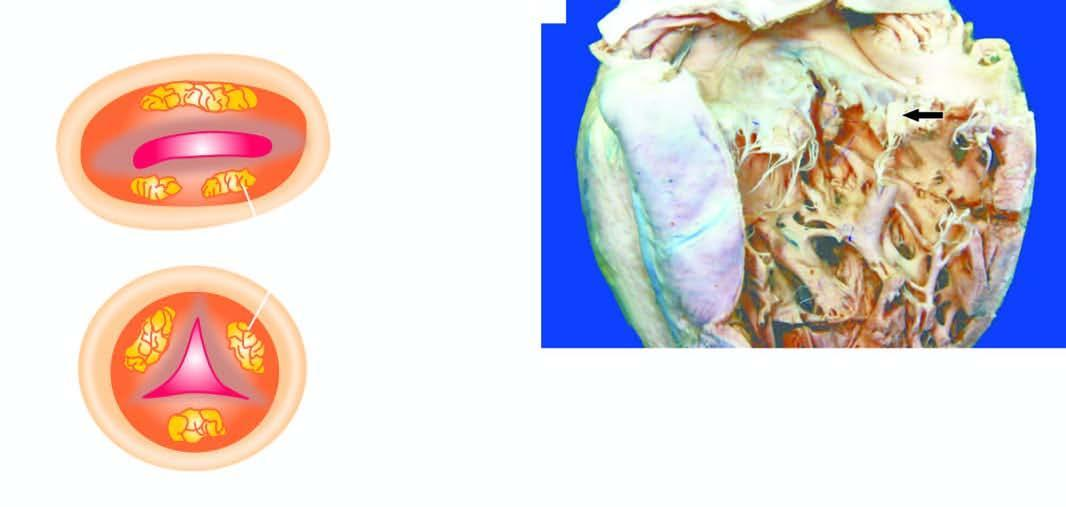what are shown on the mitral valve are shown as seen from the left ventricle?
Answer the question using a single word or phrase. Vegetations 